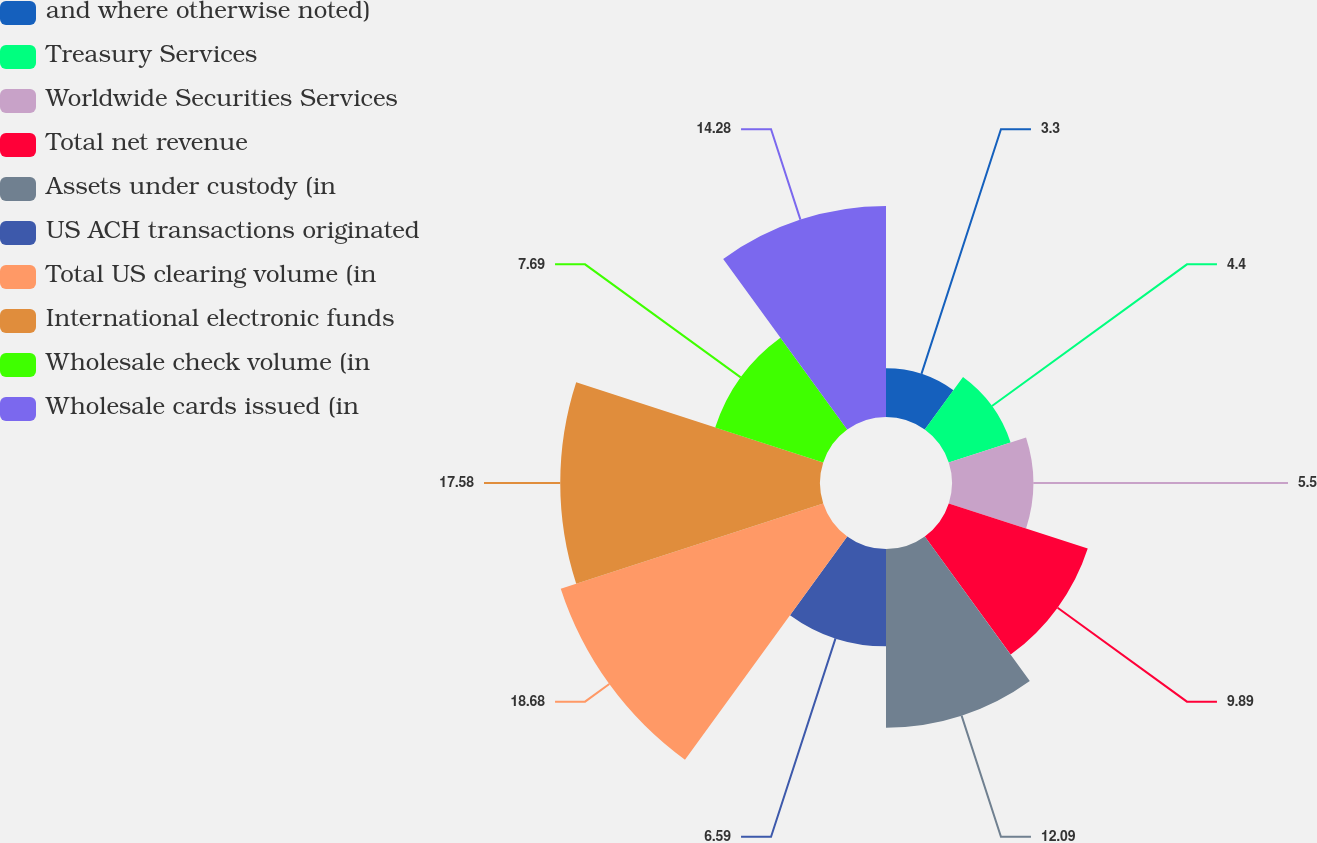Convert chart. <chart><loc_0><loc_0><loc_500><loc_500><pie_chart><fcel>and where otherwise noted)<fcel>Treasury Services<fcel>Worldwide Securities Services<fcel>Total net revenue<fcel>Assets under custody (in<fcel>US ACH transactions originated<fcel>Total US clearing volume (in<fcel>International electronic funds<fcel>Wholesale check volume (in<fcel>Wholesale cards issued (in<nl><fcel>3.3%<fcel>4.4%<fcel>5.5%<fcel>9.89%<fcel>12.09%<fcel>6.59%<fcel>18.68%<fcel>17.58%<fcel>7.69%<fcel>14.28%<nl></chart> 